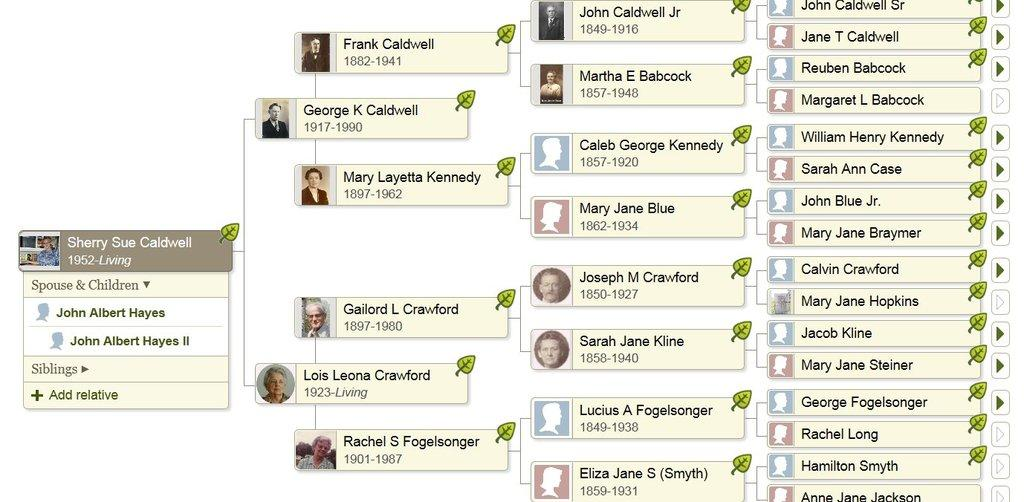What type of information is presented in the image? There is a list of names in the image. Are there any visual representations of people in the image? Yes, there are images of people in the image. What color is the background of the image? The background of the image is white in color. Can you see any steam coming from the names in the image? There is no steam present in the image, as it contains a list of names and images of people. How many clovers are visible in the image? There are no clovers present in the image. 